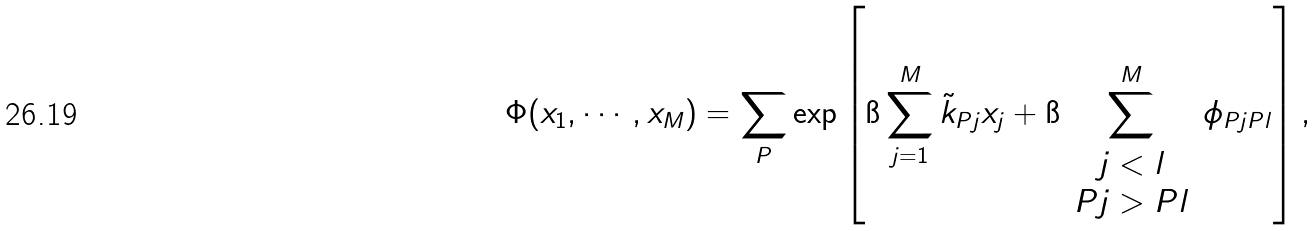<formula> <loc_0><loc_0><loc_500><loc_500>\Phi ( x _ { 1 } , \cdots , x _ { M } ) = \sum _ { P } \exp \left [ \i \sum _ { j = 1 } ^ { M } { \tilde { k } } _ { P j } x _ { j } + \i \sum _ { \begin{array} { c } j < l \\ P j > P l \end{array} } ^ { M } \phi _ { P j P l } \right ] ,</formula> 